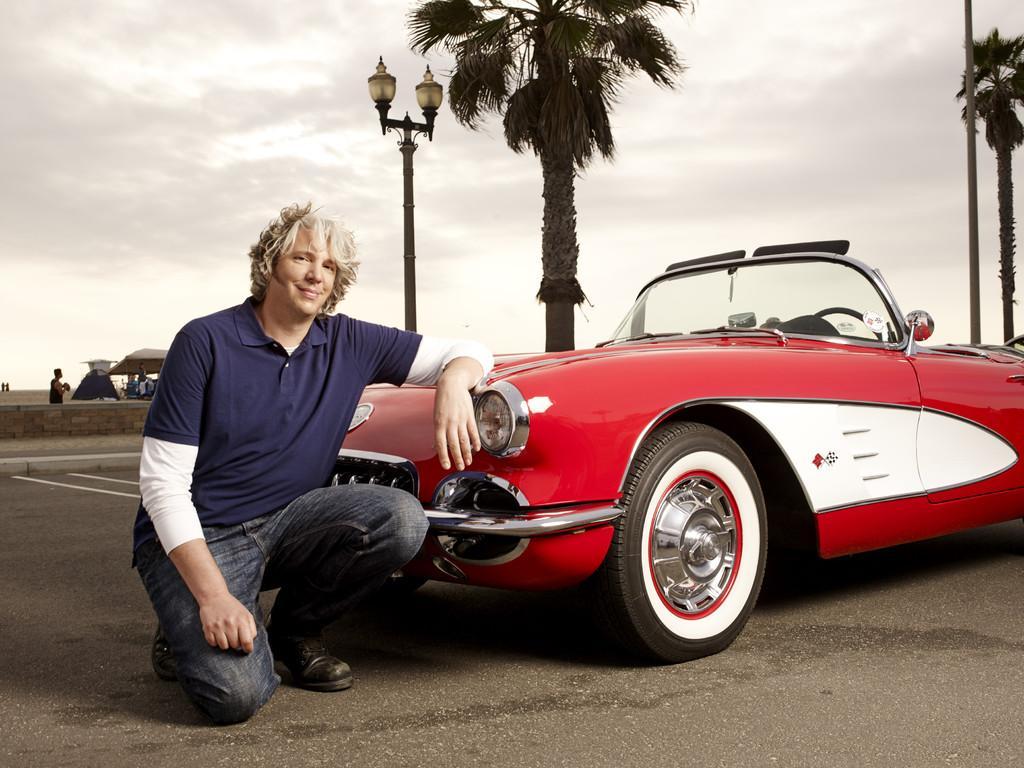In one or two sentences, can you explain what this image depicts? In this image there is a car on the road. In front of it there is a man kneeling on the ground. Behind the car there are trees and street light poles. To the left there are tents and a few people in the background. At the top there is the sky. 